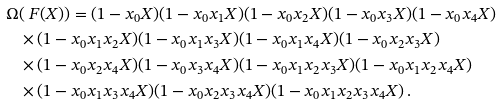<formula> <loc_0><loc_0><loc_500><loc_500>\Omega & ( \ F ( X ) ) = ( 1 - x _ { 0 } X ) ( 1 - x _ { 0 } x _ { 1 } X ) ( 1 - x _ { 0 } x _ { 2 } X ) ( 1 - x _ { 0 } x _ { 3 } X ) ( 1 - x _ { 0 } x _ { 4 } X ) \\ & \times ( 1 - x _ { 0 } x _ { 1 } x _ { 2 } X ) ( 1 - x _ { 0 } x _ { 1 } x _ { 3 } X ) ( 1 - x _ { 0 } x _ { 1 } x _ { 4 } X ) ( 1 - x _ { 0 } x _ { 2 } x _ { 3 } X ) \\ & \times ( 1 - x _ { 0 } x _ { 2 } x _ { 4 } X ) ( 1 - x _ { 0 } x _ { 3 } x _ { 4 } X ) ( 1 - x _ { 0 } x _ { 1 } x _ { 2 } x _ { 3 } X ) ( 1 - x _ { 0 } x _ { 1 } x _ { 2 } x _ { 4 } X ) \\ & \times ( 1 - x _ { 0 } x _ { 1 } x _ { 3 } x _ { 4 } X ) ( 1 - x _ { 0 } x _ { 2 } x _ { 3 } x _ { 4 } X ) ( 1 - x _ { 0 } x _ { 1 } x _ { 2 } x _ { 3 } x _ { 4 } X ) \, .</formula> 